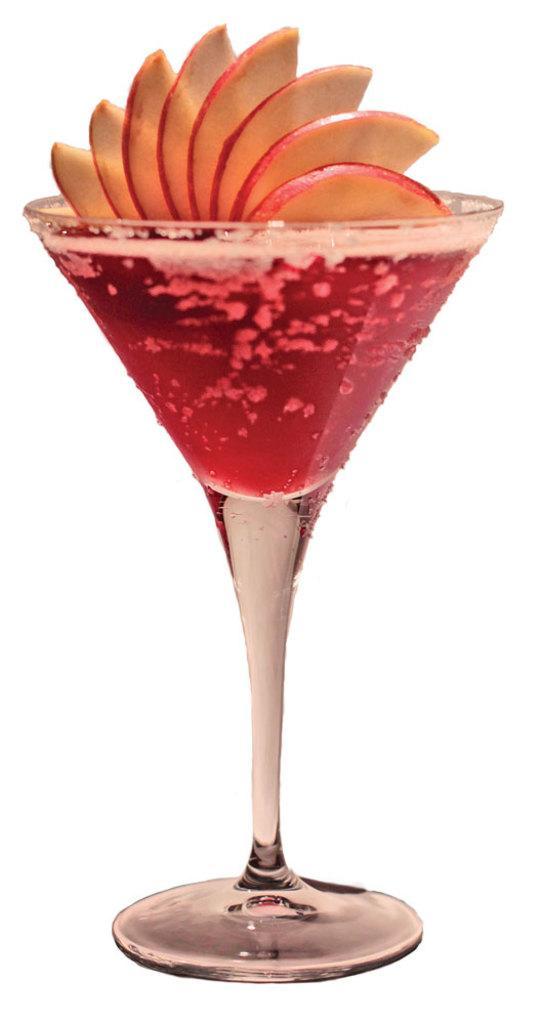In one or two sentences, can you explain what this image depicts? In this picture I can see there is a glass of juice served and there are apple slices placed and in the backdrop there is a white surface. 